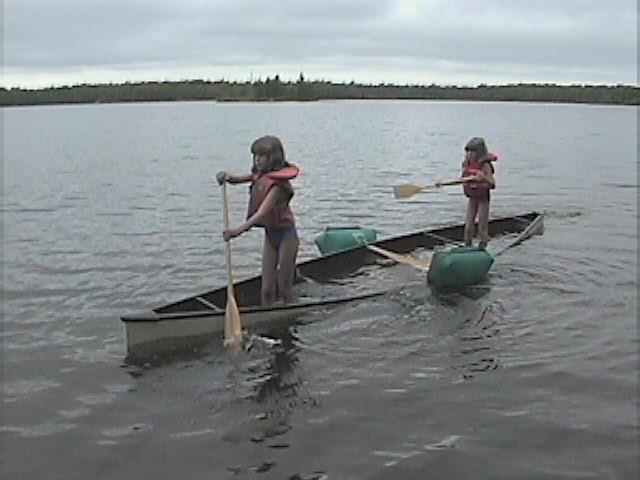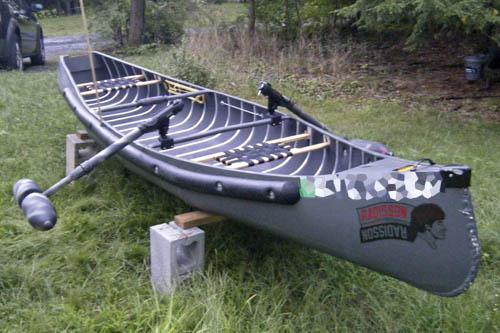The first image is the image on the left, the second image is the image on the right. Evaluate the accuracy of this statement regarding the images: "An image shows a man without a cap sitting in a traditional canoe gripping an oar in each hand, with his arms and body in position to pull the oars back.". Is it true? Answer yes or no. No. The first image is the image on the left, the second image is the image on the right. Given the left and right images, does the statement "The left and right image contains the same number of small crafts in the water." hold true? Answer yes or no. No. 